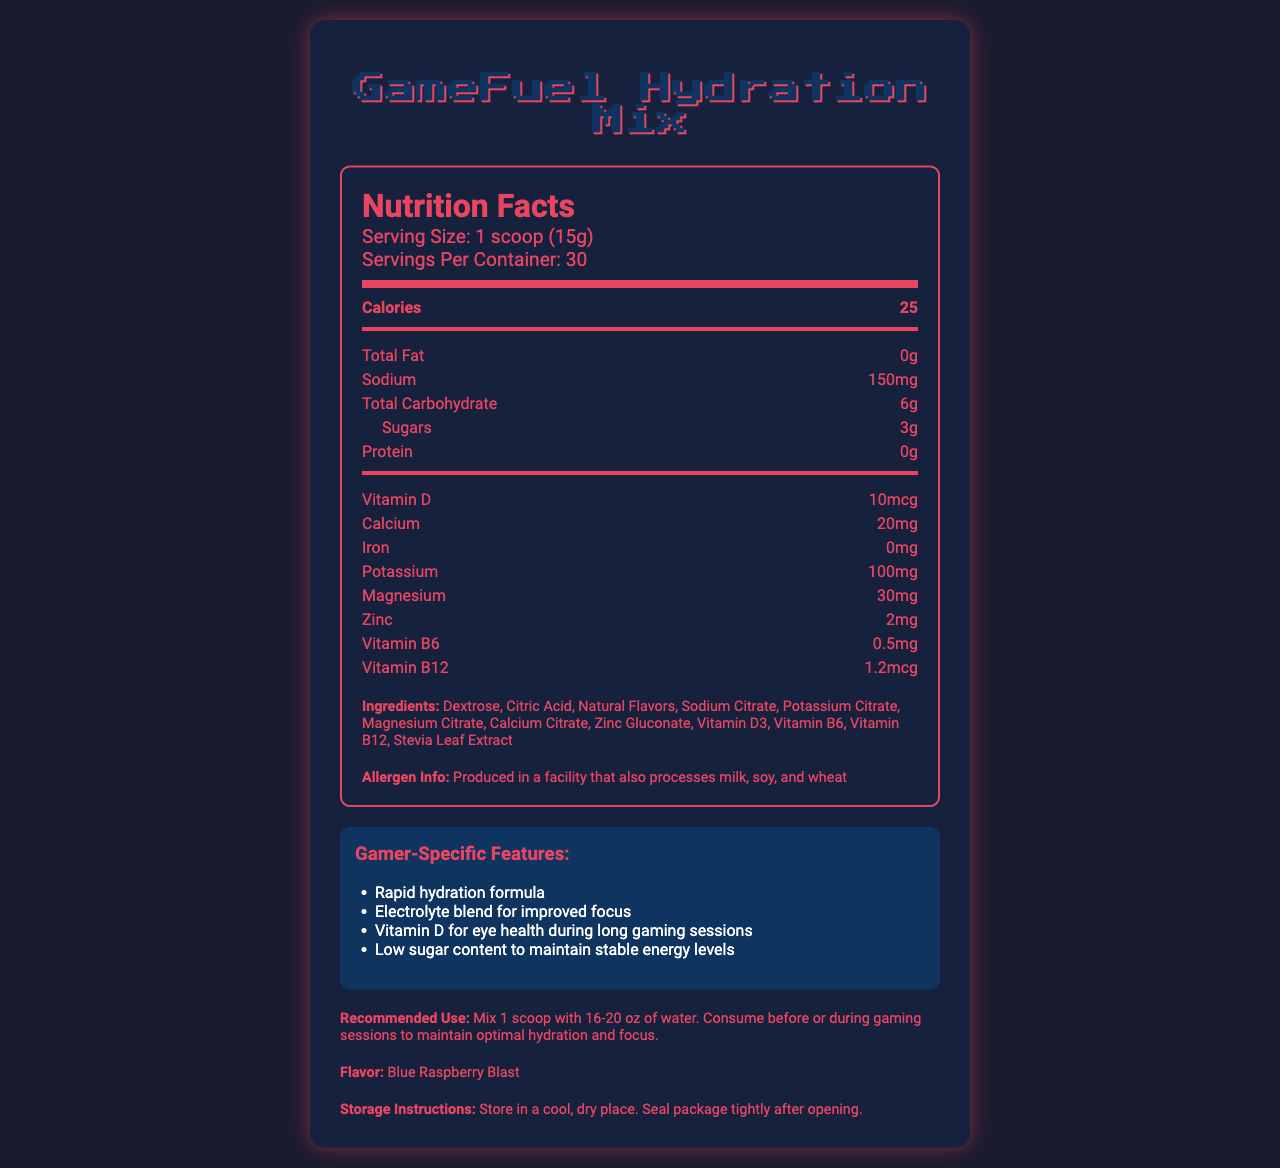what is the serving size? The serving size is specified at the beginning of the Nutrition Facts section of the document.
Answer: 1 scoop (15g) how many calories are there per serving? The document lists the calories in a serving under the Nutrition Facts section.
Answer: 25 what is the recommended use for this product? This information is provided under the Recommended Use section of the document.
Answer: Mix 1 scoop with 16-20 oz of water. Consume before or during gaming sessions to maintain optimal hydration and focus. how many servings are there per container? The document specifies the number of servings per container right after the serving size.
Answer: 30 how much Vitamin D is in each serving? The amount of Vitamin D per serving is listed under the Nutrition Facts section.
Answer: 10 mcg what is the flavor of the hydration mix? The flavor is listed at the end of the document under the Flavor section.
Answer: Blue Raspberry Blast which ingredient is listed first? The ingredients are listed in descending order of their amount in the product, with Dextrose being the first.
Answer: Dextrose what is the intended benefit of the electrolyte blend? A. Enhanced taste B. Improved focus C. Muscle recovery D. Better sleep The document states that the electrolyte blend is for improved focus among gamers.
Answer: B are there any allergens listed in the product? The document provides allergen information indicating that it is produced in a facility that also processes milk, soy, and wheat.
Answer: Yes is there any protein in a serving? The Nutrition Facts section shows that there is 0g of protein per serving.
Answer: No does the product contain any iron? The Nutrition Facts section lists the iron content as 0mg.
Answer: No how should the package be stored after opening? The storage instructions are provided at the end of the document.
Answer: Store in a cool, dry place. Seal package tightly after opening. summarize the main idea of the document. This summary captures the key elements of the document including its purpose, target audience, nutritional composition, and usage instructions.
Answer: GameFuel Hydration Mix is a hydration powder mix designed for gamers, featuring electrolytes, low sugar, and vitamins including Vitamin D. It aims to improve focus and maintain stable energy levels. The product includes nutrition facts, ingredients, allergen information, and recommended use guidelines. how much vitamin B6 is in each serving? The amount of Vitamin B6 per serving is listed under the Nutrition Facts section.
Answer: 0.5 mg what is the total carbohydrate content per serving? The total carbohydrate content is listed under the Nutrition Facts section.
Answer: 6g does the product contain artificial flavors? The document lists "Natural Flavors" in the ingredients section, implying the absence of artificial flavors.
Answer: No how many different vitamins are included in the product? The product contains Vitamins D, B6, and B12 as listed in the Nutrition Facts section.
Answer: 4 is the product intended for weight loss? The document does not provide information on whether the product is intended for weight loss, focusing instead on hydration and focus.
Answer: Not enough information 